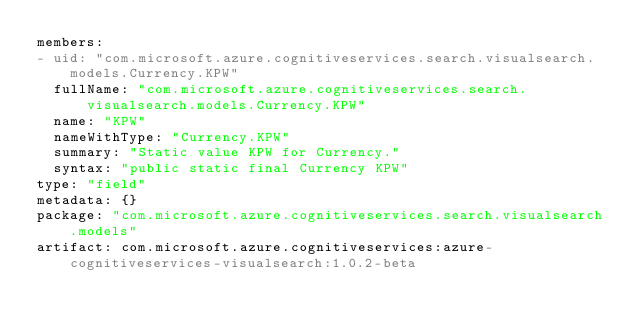Convert code to text. <code><loc_0><loc_0><loc_500><loc_500><_YAML_>members:
- uid: "com.microsoft.azure.cognitiveservices.search.visualsearch.models.Currency.KPW"
  fullName: "com.microsoft.azure.cognitiveservices.search.visualsearch.models.Currency.KPW"
  name: "KPW"
  nameWithType: "Currency.KPW"
  summary: "Static value KPW for Currency."
  syntax: "public static final Currency KPW"
type: "field"
metadata: {}
package: "com.microsoft.azure.cognitiveservices.search.visualsearch.models"
artifact: com.microsoft.azure.cognitiveservices:azure-cognitiveservices-visualsearch:1.0.2-beta
</code> 